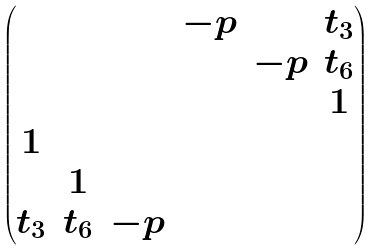<formula> <loc_0><loc_0><loc_500><loc_500>\begin{pmatrix} & & & - p & & t _ { 3 } \\ & & & & - p & t _ { 6 } \\ & & & & & 1 \\ 1 & & & & \\ & 1 & \\ t _ { 3 } & t _ { 6 } & - p & \\ \end{pmatrix}</formula> 